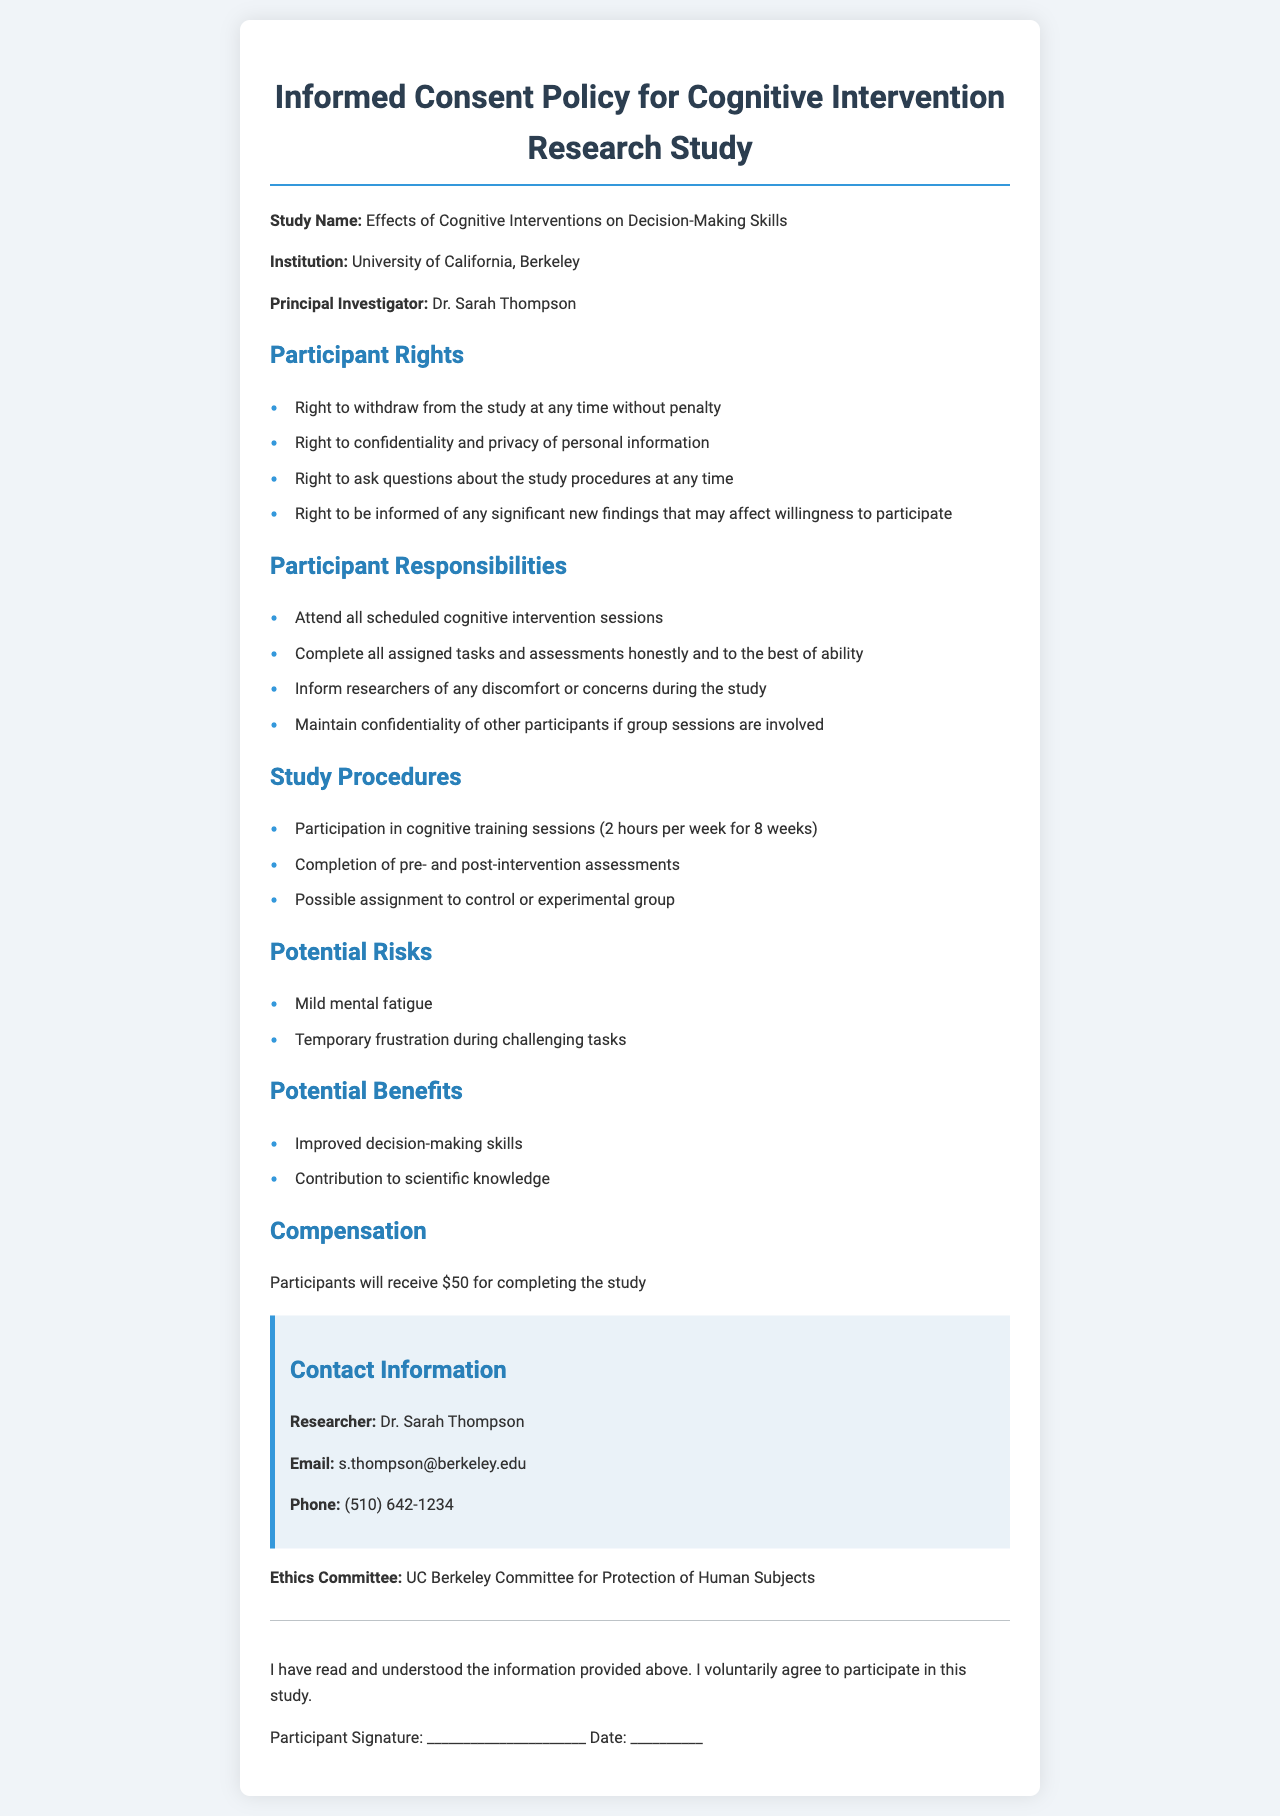what is the study name? The study name is stated at the beginning of the document, which is "Effects of Cognitive Interventions on Decision-Making Skills."
Answer: Effects of Cognitive Interventions on Decision-Making Skills who is the principal investigator? The principal investigator's name is mentioned in the document as leading the research effort.
Answer: Dr. Sarah Thompson how long is the participation in cognitive training sessions? The document specifies the duration of the training sessions, which is 2 hours per week for 8 weeks.
Answer: 2 hours per week for 8 weeks what is the compensation for completing the study? The compensation amount for participants who complete the study is provided in the document.
Answer: $50 what right do participants have regarding their privacy? The document states specific rights participants have, including their right to confidentiality and privacy of personal information.
Answer: Right to confidentiality and privacy how many potential risks are mentioned in the document? The document lists specific potential risks of participation, indicating the total count is important for understanding participant safety.
Answer: 2 what should participants do if they experience discomfort during the study? The document outlines participant responsibilities including actions regarding discomfort during participation in the study.
Answer: Inform researchers what group assignment may participants face? The document mentions that participants may be assigned to different groups as part of the study procedures.
Answer: Control or experimental group who can participants contact for more information? The document provides specific contact details for a researcher for participants to reach out to for inquiries.
Answer: Dr. Sarah Thompson 